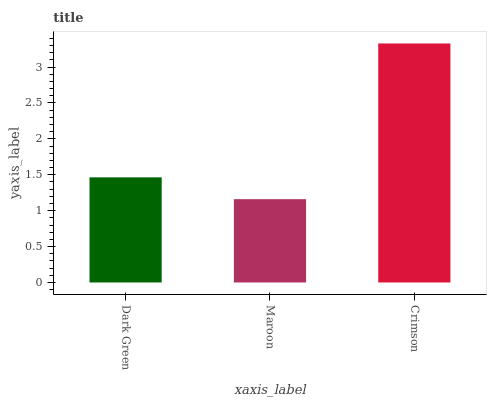Is Maroon the minimum?
Answer yes or no. Yes. Is Crimson the maximum?
Answer yes or no. Yes. Is Crimson the minimum?
Answer yes or no. No. Is Maroon the maximum?
Answer yes or no. No. Is Crimson greater than Maroon?
Answer yes or no. Yes. Is Maroon less than Crimson?
Answer yes or no. Yes. Is Maroon greater than Crimson?
Answer yes or no. No. Is Crimson less than Maroon?
Answer yes or no. No. Is Dark Green the high median?
Answer yes or no. Yes. Is Dark Green the low median?
Answer yes or no. Yes. Is Maroon the high median?
Answer yes or no. No. Is Crimson the low median?
Answer yes or no. No. 